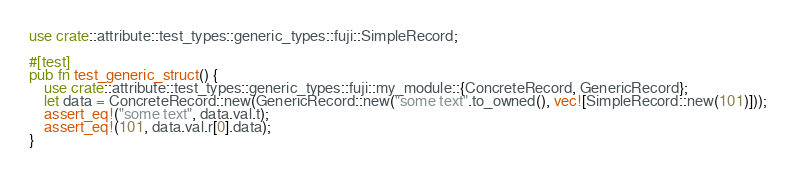Convert code to text. <code><loc_0><loc_0><loc_500><loc_500><_Rust_>use crate::attribute::test_types::generic_types::fuji::SimpleRecord;

#[test]
pub fn test_generic_struct() {
    use crate::attribute::test_types::generic_types::fuji::my_module::{ConcreteRecord, GenericRecord};
    let data = ConcreteRecord::new(GenericRecord::new("some text".to_owned(), vec![SimpleRecord::new(101)]));
    assert_eq!("some text", data.val.t);
    assert_eq!(101, data.val.r[0].data);
}
</code> 